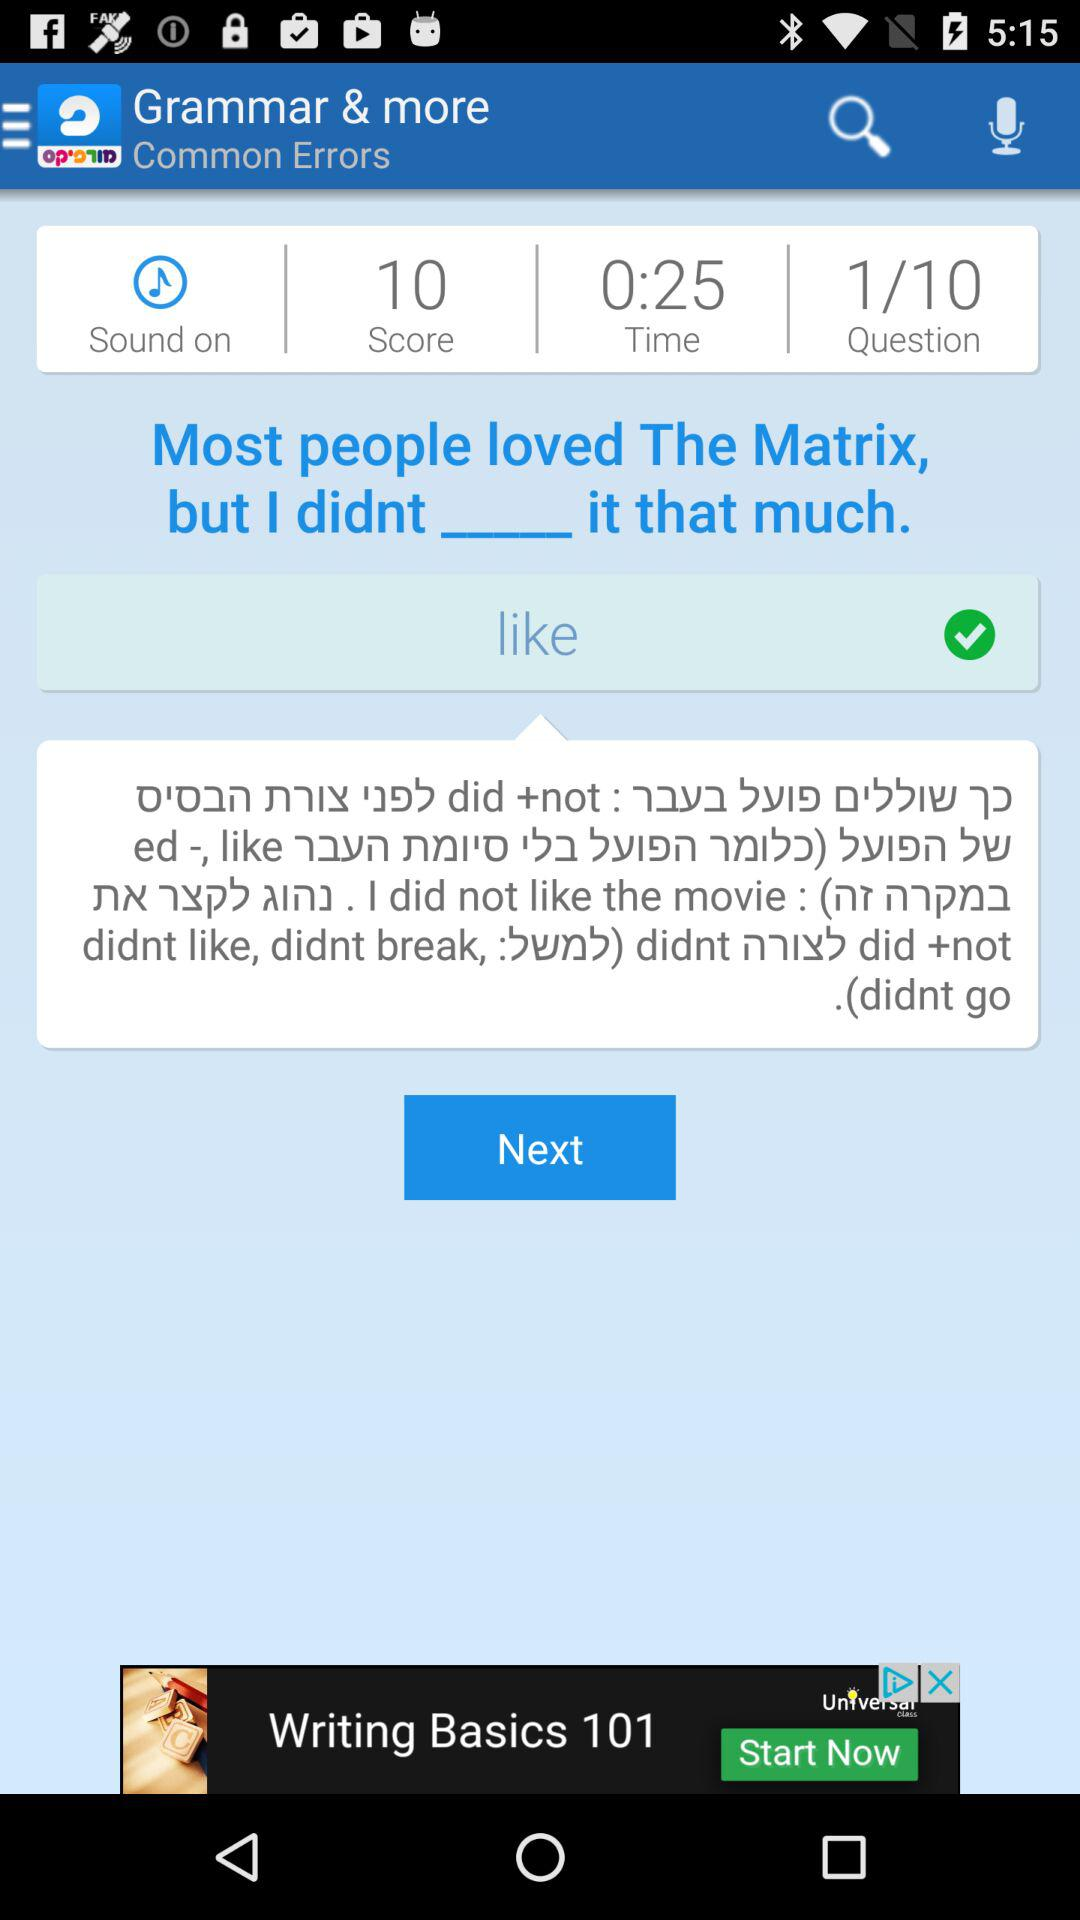What is the score? The score is 10. 